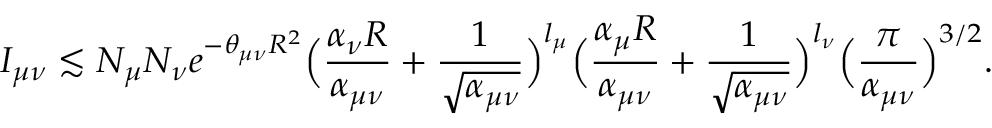Convert formula to latex. <formula><loc_0><loc_0><loc_500><loc_500>I _ { \mu \nu } \lesssim N _ { \mu } N _ { \nu } e ^ { - \theta _ { \mu \nu } R ^ { 2 } } \left ( \frac { \alpha _ { \nu } R } { \alpha _ { \mu \nu } } + \frac { 1 } { \sqrt { \alpha _ { \mu \nu } } } \right ) ^ { l _ { \mu } } \left ( \frac { \alpha _ { \mu } R } { \alpha _ { \mu \nu } } + \frac { 1 } { \sqrt { \alpha _ { \mu \nu } } } \right ) ^ { l _ { \nu } } \left ( \frac { \pi } { \alpha _ { \mu \nu } } \right ) ^ { 3 / 2 } .</formula> 